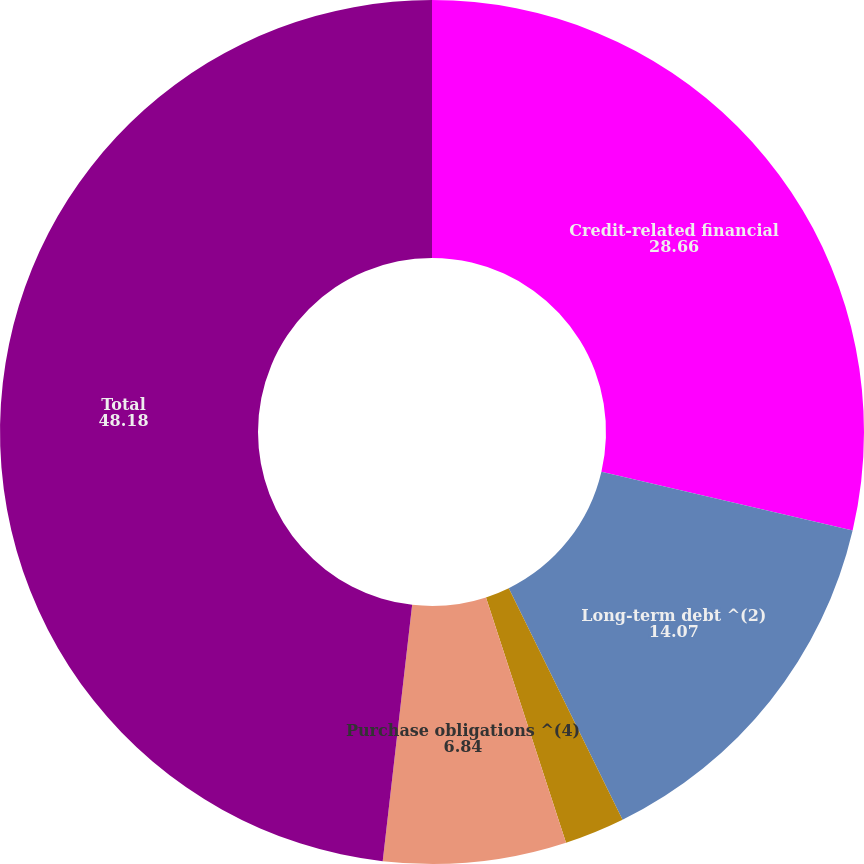Convert chart. <chart><loc_0><loc_0><loc_500><loc_500><pie_chart><fcel>Credit-related financial<fcel>Long-term debt ^(2)<fcel>Leases ^(3)<fcel>Purchase obligations ^(4)<fcel>Total<nl><fcel>28.66%<fcel>14.07%<fcel>2.25%<fcel>6.84%<fcel>48.18%<nl></chart> 